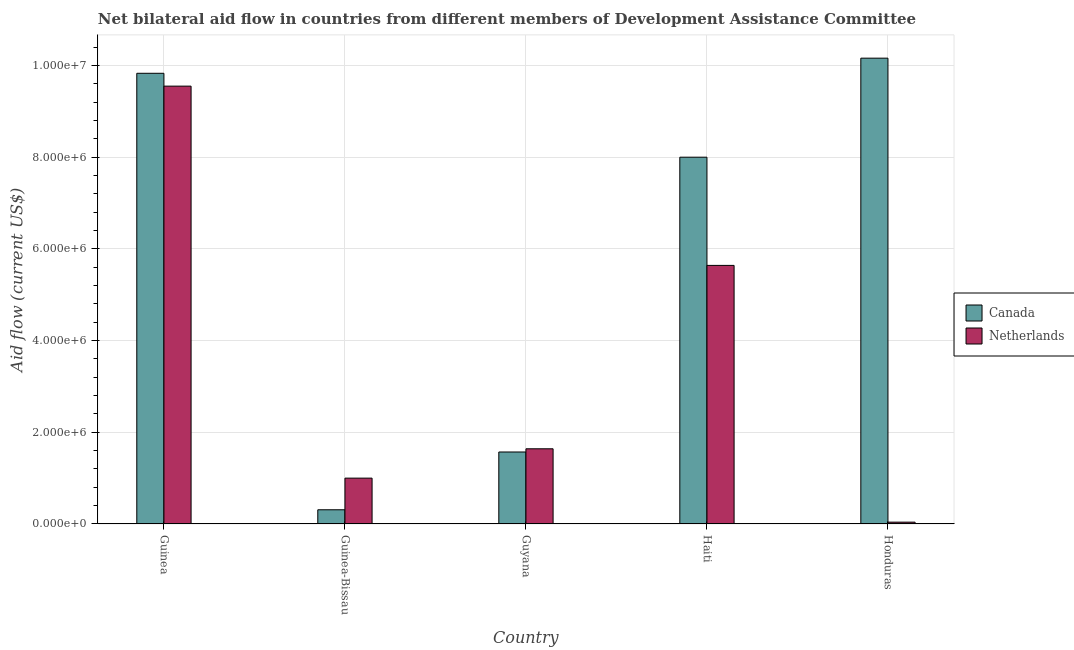How many different coloured bars are there?
Provide a succinct answer. 2. How many groups of bars are there?
Your response must be concise. 5. Are the number of bars per tick equal to the number of legend labels?
Make the answer very short. Yes. Are the number of bars on each tick of the X-axis equal?
Ensure brevity in your answer.  Yes. What is the label of the 3rd group of bars from the left?
Your answer should be compact. Guyana. What is the amount of aid given by canada in Guinea-Bissau?
Your answer should be compact. 3.10e+05. Across all countries, what is the maximum amount of aid given by netherlands?
Ensure brevity in your answer.  9.55e+06. Across all countries, what is the minimum amount of aid given by canada?
Offer a terse response. 3.10e+05. In which country was the amount of aid given by netherlands maximum?
Offer a very short reply. Guinea. In which country was the amount of aid given by netherlands minimum?
Provide a short and direct response. Honduras. What is the total amount of aid given by canada in the graph?
Offer a very short reply. 2.99e+07. What is the difference between the amount of aid given by netherlands in Guyana and that in Honduras?
Provide a succinct answer. 1.60e+06. What is the difference between the amount of aid given by canada in Guyana and the amount of aid given by netherlands in Haiti?
Your answer should be compact. -4.07e+06. What is the average amount of aid given by netherlands per country?
Your answer should be compact. 3.57e+06. What is the difference between the amount of aid given by netherlands and amount of aid given by canada in Guinea?
Your answer should be very brief. -2.80e+05. What is the ratio of the amount of aid given by canada in Guinea-Bissau to that in Guyana?
Your answer should be compact. 0.2. Is the difference between the amount of aid given by canada in Guinea-Bissau and Haiti greater than the difference between the amount of aid given by netherlands in Guinea-Bissau and Haiti?
Your response must be concise. No. What is the difference between the highest and the second highest amount of aid given by canada?
Your response must be concise. 3.30e+05. What is the difference between the highest and the lowest amount of aid given by canada?
Provide a succinct answer. 9.85e+06. What does the 1st bar from the left in Haiti represents?
Your answer should be compact. Canada. What does the 1st bar from the right in Guinea represents?
Provide a succinct answer. Netherlands. How many bars are there?
Provide a succinct answer. 10. Are all the bars in the graph horizontal?
Make the answer very short. No. How many countries are there in the graph?
Ensure brevity in your answer.  5. What is the difference between two consecutive major ticks on the Y-axis?
Make the answer very short. 2.00e+06. Are the values on the major ticks of Y-axis written in scientific E-notation?
Your response must be concise. Yes. What is the title of the graph?
Provide a succinct answer. Net bilateral aid flow in countries from different members of Development Assistance Committee. Does "constant 2005 US$" appear as one of the legend labels in the graph?
Keep it short and to the point. No. What is the Aid flow (current US$) of Canada in Guinea?
Give a very brief answer. 9.83e+06. What is the Aid flow (current US$) in Netherlands in Guinea?
Your answer should be very brief. 9.55e+06. What is the Aid flow (current US$) in Netherlands in Guinea-Bissau?
Provide a short and direct response. 1.00e+06. What is the Aid flow (current US$) in Canada in Guyana?
Your response must be concise. 1.57e+06. What is the Aid flow (current US$) in Netherlands in Guyana?
Ensure brevity in your answer.  1.64e+06. What is the Aid flow (current US$) in Canada in Haiti?
Offer a terse response. 8.00e+06. What is the Aid flow (current US$) of Netherlands in Haiti?
Give a very brief answer. 5.64e+06. What is the Aid flow (current US$) in Canada in Honduras?
Provide a short and direct response. 1.02e+07. What is the Aid flow (current US$) of Netherlands in Honduras?
Provide a short and direct response. 4.00e+04. Across all countries, what is the maximum Aid flow (current US$) in Canada?
Make the answer very short. 1.02e+07. Across all countries, what is the maximum Aid flow (current US$) of Netherlands?
Give a very brief answer. 9.55e+06. Across all countries, what is the minimum Aid flow (current US$) of Netherlands?
Your response must be concise. 4.00e+04. What is the total Aid flow (current US$) of Canada in the graph?
Give a very brief answer. 2.99e+07. What is the total Aid flow (current US$) in Netherlands in the graph?
Offer a terse response. 1.79e+07. What is the difference between the Aid flow (current US$) of Canada in Guinea and that in Guinea-Bissau?
Your answer should be very brief. 9.52e+06. What is the difference between the Aid flow (current US$) of Netherlands in Guinea and that in Guinea-Bissau?
Give a very brief answer. 8.55e+06. What is the difference between the Aid flow (current US$) of Canada in Guinea and that in Guyana?
Give a very brief answer. 8.26e+06. What is the difference between the Aid flow (current US$) in Netherlands in Guinea and that in Guyana?
Give a very brief answer. 7.91e+06. What is the difference between the Aid flow (current US$) of Canada in Guinea and that in Haiti?
Give a very brief answer. 1.83e+06. What is the difference between the Aid flow (current US$) of Netherlands in Guinea and that in Haiti?
Your response must be concise. 3.91e+06. What is the difference between the Aid flow (current US$) of Canada in Guinea and that in Honduras?
Keep it short and to the point. -3.30e+05. What is the difference between the Aid flow (current US$) of Netherlands in Guinea and that in Honduras?
Your answer should be very brief. 9.51e+06. What is the difference between the Aid flow (current US$) in Canada in Guinea-Bissau and that in Guyana?
Keep it short and to the point. -1.26e+06. What is the difference between the Aid flow (current US$) of Netherlands in Guinea-Bissau and that in Guyana?
Give a very brief answer. -6.40e+05. What is the difference between the Aid flow (current US$) in Canada in Guinea-Bissau and that in Haiti?
Provide a succinct answer. -7.69e+06. What is the difference between the Aid flow (current US$) of Netherlands in Guinea-Bissau and that in Haiti?
Make the answer very short. -4.64e+06. What is the difference between the Aid flow (current US$) in Canada in Guinea-Bissau and that in Honduras?
Provide a short and direct response. -9.85e+06. What is the difference between the Aid flow (current US$) of Netherlands in Guinea-Bissau and that in Honduras?
Keep it short and to the point. 9.60e+05. What is the difference between the Aid flow (current US$) in Canada in Guyana and that in Haiti?
Make the answer very short. -6.43e+06. What is the difference between the Aid flow (current US$) in Canada in Guyana and that in Honduras?
Make the answer very short. -8.59e+06. What is the difference between the Aid flow (current US$) of Netherlands in Guyana and that in Honduras?
Your answer should be compact. 1.60e+06. What is the difference between the Aid flow (current US$) in Canada in Haiti and that in Honduras?
Provide a short and direct response. -2.16e+06. What is the difference between the Aid flow (current US$) of Netherlands in Haiti and that in Honduras?
Make the answer very short. 5.60e+06. What is the difference between the Aid flow (current US$) of Canada in Guinea and the Aid flow (current US$) of Netherlands in Guinea-Bissau?
Provide a short and direct response. 8.83e+06. What is the difference between the Aid flow (current US$) in Canada in Guinea and the Aid flow (current US$) in Netherlands in Guyana?
Give a very brief answer. 8.19e+06. What is the difference between the Aid flow (current US$) of Canada in Guinea and the Aid flow (current US$) of Netherlands in Haiti?
Offer a very short reply. 4.19e+06. What is the difference between the Aid flow (current US$) in Canada in Guinea and the Aid flow (current US$) in Netherlands in Honduras?
Give a very brief answer. 9.79e+06. What is the difference between the Aid flow (current US$) in Canada in Guinea-Bissau and the Aid flow (current US$) in Netherlands in Guyana?
Make the answer very short. -1.33e+06. What is the difference between the Aid flow (current US$) of Canada in Guinea-Bissau and the Aid flow (current US$) of Netherlands in Haiti?
Offer a terse response. -5.33e+06. What is the difference between the Aid flow (current US$) of Canada in Guyana and the Aid flow (current US$) of Netherlands in Haiti?
Provide a short and direct response. -4.07e+06. What is the difference between the Aid flow (current US$) in Canada in Guyana and the Aid flow (current US$) in Netherlands in Honduras?
Ensure brevity in your answer.  1.53e+06. What is the difference between the Aid flow (current US$) in Canada in Haiti and the Aid flow (current US$) in Netherlands in Honduras?
Provide a succinct answer. 7.96e+06. What is the average Aid flow (current US$) in Canada per country?
Provide a succinct answer. 5.97e+06. What is the average Aid flow (current US$) in Netherlands per country?
Offer a very short reply. 3.57e+06. What is the difference between the Aid flow (current US$) in Canada and Aid flow (current US$) in Netherlands in Guinea?
Make the answer very short. 2.80e+05. What is the difference between the Aid flow (current US$) in Canada and Aid flow (current US$) in Netherlands in Guinea-Bissau?
Your answer should be very brief. -6.90e+05. What is the difference between the Aid flow (current US$) of Canada and Aid flow (current US$) of Netherlands in Guyana?
Ensure brevity in your answer.  -7.00e+04. What is the difference between the Aid flow (current US$) in Canada and Aid flow (current US$) in Netherlands in Haiti?
Your answer should be very brief. 2.36e+06. What is the difference between the Aid flow (current US$) in Canada and Aid flow (current US$) in Netherlands in Honduras?
Your answer should be very brief. 1.01e+07. What is the ratio of the Aid flow (current US$) of Canada in Guinea to that in Guinea-Bissau?
Your response must be concise. 31.71. What is the ratio of the Aid flow (current US$) in Netherlands in Guinea to that in Guinea-Bissau?
Provide a short and direct response. 9.55. What is the ratio of the Aid flow (current US$) of Canada in Guinea to that in Guyana?
Give a very brief answer. 6.26. What is the ratio of the Aid flow (current US$) in Netherlands in Guinea to that in Guyana?
Give a very brief answer. 5.82. What is the ratio of the Aid flow (current US$) of Canada in Guinea to that in Haiti?
Keep it short and to the point. 1.23. What is the ratio of the Aid flow (current US$) of Netherlands in Guinea to that in Haiti?
Make the answer very short. 1.69. What is the ratio of the Aid flow (current US$) in Canada in Guinea to that in Honduras?
Offer a terse response. 0.97. What is the ratio of the Aid flow (current US$) of Netherlands in Guinea to that in Honduras?
Your answer should be very brief. 238.75. What is the ratio of the Aid flow (current US$) in Canada in Guinea-Bissau to that in Guyana?
Your answer should be compact. 0.2. What is the ratio of the Aid flow (current US$) of Netherlands in Guinea-Bissau to that in Guyana?
Provide a succinct answer. 0.61. What is the ratio of the Aid flow (current US$) of Canada in Guinea-Bissau to that in Haiti?
Offer a very short reply. 0.04. What is the ratio of the Aid flow (current US$) of Netherlands in Guinea-Bissau to that in Haiti?
Your response must be concise. 0.18. What is the ratio of the Aid flow (current US$) in Canada in Guinea-Bissau to that in Honduras?
Make the answer very short. 0.03. What is the ratio of the Aid flow (current US$) in Canada in Guyana to that in Haiti?
Your answer should be compact. 0.2. What is the ratio of the Aid flow (current US$) in Netherlands in Guyana to that in Haiti?
Provide a succinct answer. 0.29. What is the ratio of the Aid flow (current US$) in Canada in Guyana to that in Honduras?
Provide a short and direct response. 0.15. What is the ratio of the Aid flow (current US$) in Canada in Haiti to that in Honduras?
Give a very brief answer. 0.79. What is the ratio of the Aid flow (current US$) of Netherlands in Haiti to that in Honduras?
Give a very brief answer. 141. What is the difference between the highest and the second highest Aid flow (current US$) in Canada?
Give a very brief answer. 3.30e+05. What is the difference between the highest and the second highest Aid flow (current US$) in Netherlands?
Your response must be concise. 3.91e+06. What is the difference between the highest and the lowest Aid flow (current US$) of Canada?
Provide a short and direct response. 9.85e+06. What is the difference between the highest and the lowest Aid flow (current US$) in Netherlands?
Provide a short and direct response. 9.51e+06. 